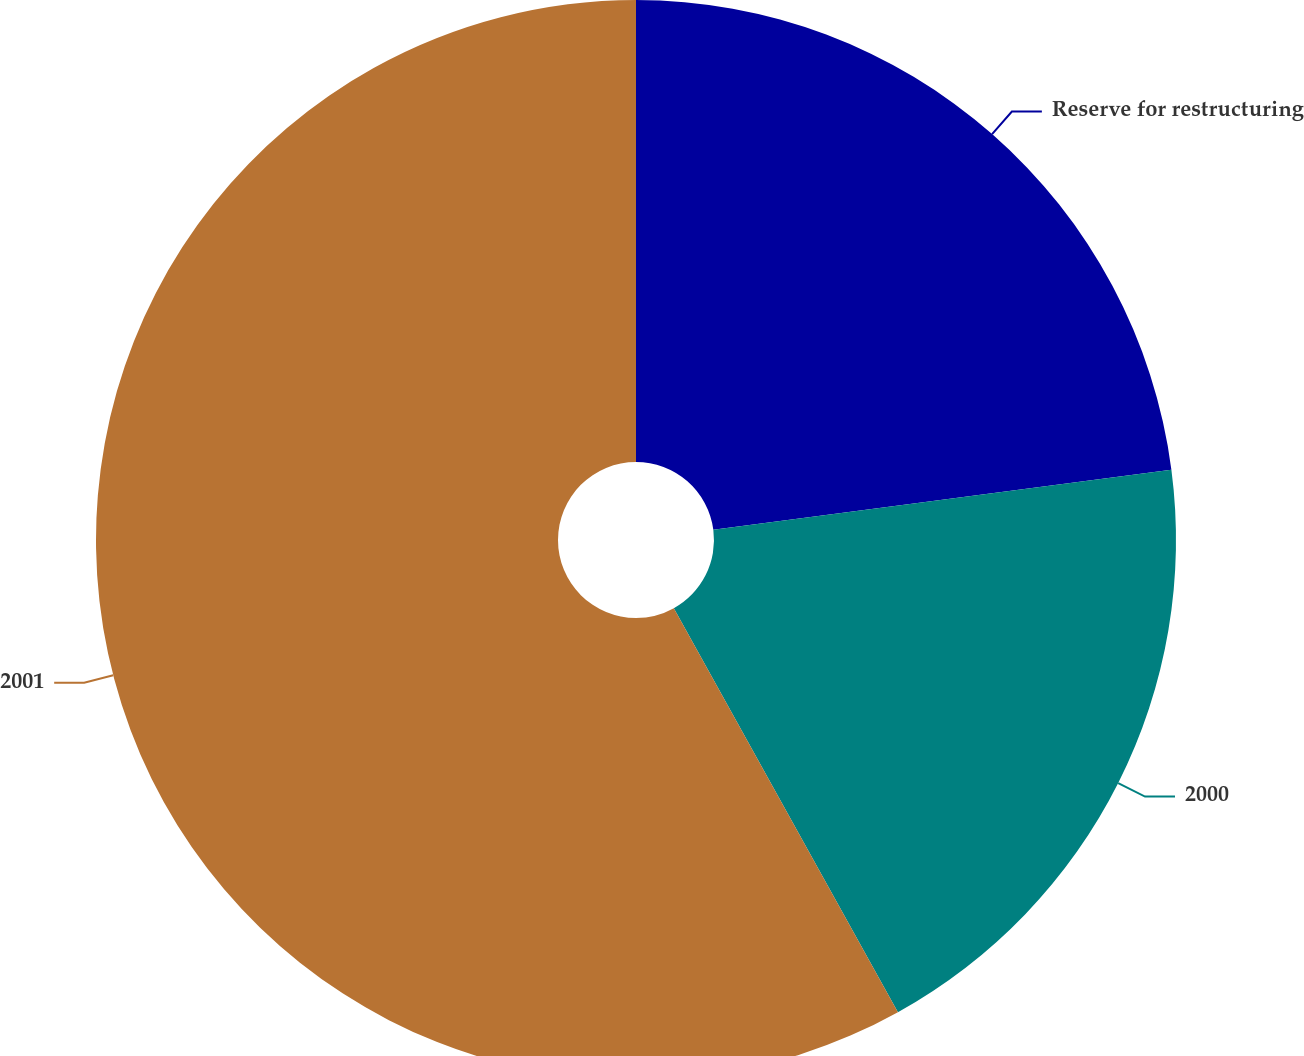<chart> <loc_0><loc_0><loc_500><loc_500><pie_chart><fcel>Reserve for restructuring<fcel>2000<fcel>2001<nl><fcel>22.92%<fcel>19.02%<fcel>58.06%<nl></chart> 